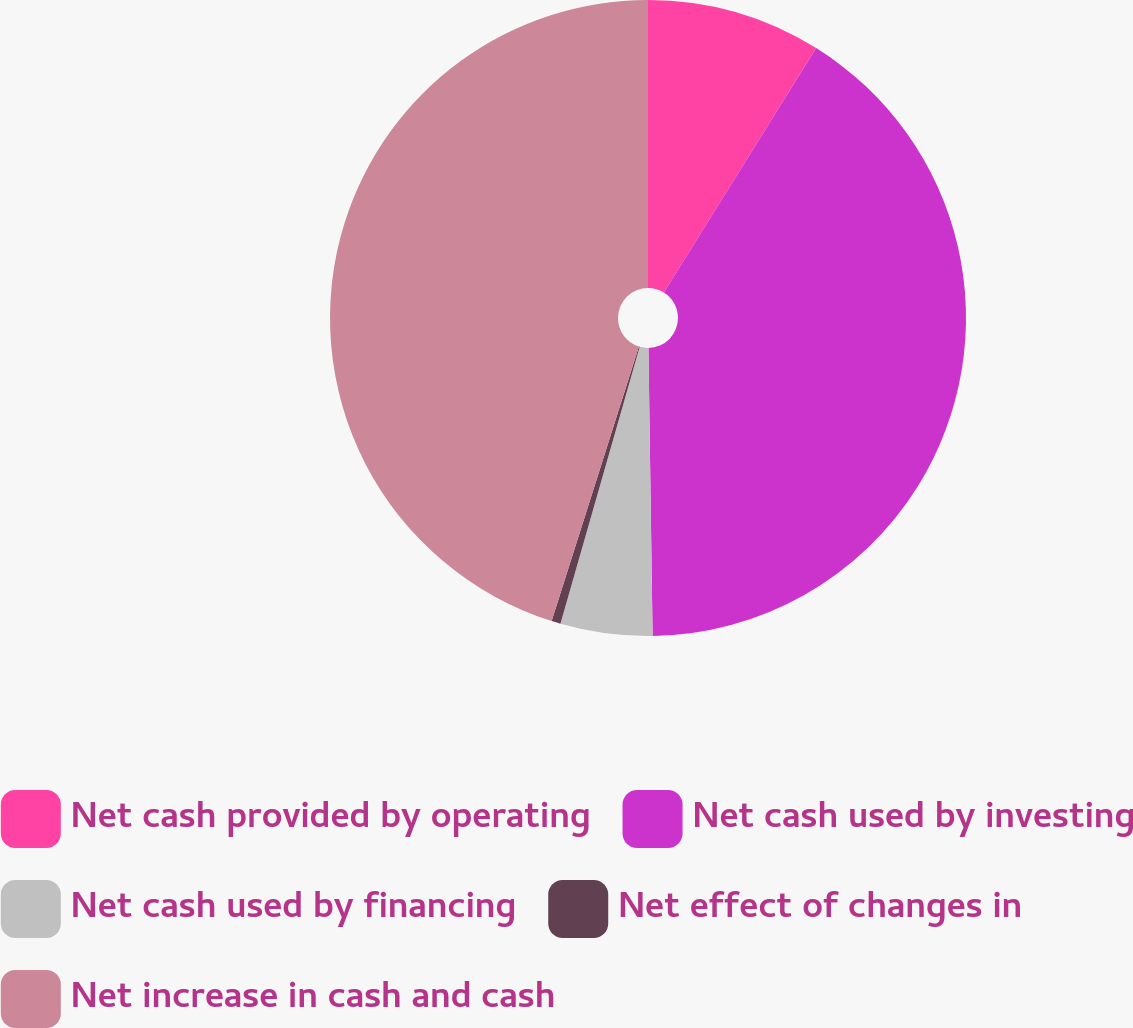Convert chart. <chart><loc_0><loc_0><loc_500><loc_500><pie_chart><fcel>Net cash provided by operating<fcel>Net cash used by investing<fcel>Net cash used by financing<fcel>Net effect of changes in<fcel>Net increase in cash and cash<nl><fcel>8.87%<fcel>40.9%<fcel>4.67%<fcel>0.46%<fcel>45.1%<nl></chart> 